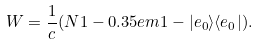<formula> <loc_0><loc_0><loc_500><loc_500>W = \frac { 1 } { c } ( N 1 - 0 . 3 5 e m 1 - | e _ { 0 } \rangle \langle e _ { 0 } | ) .</formula> 